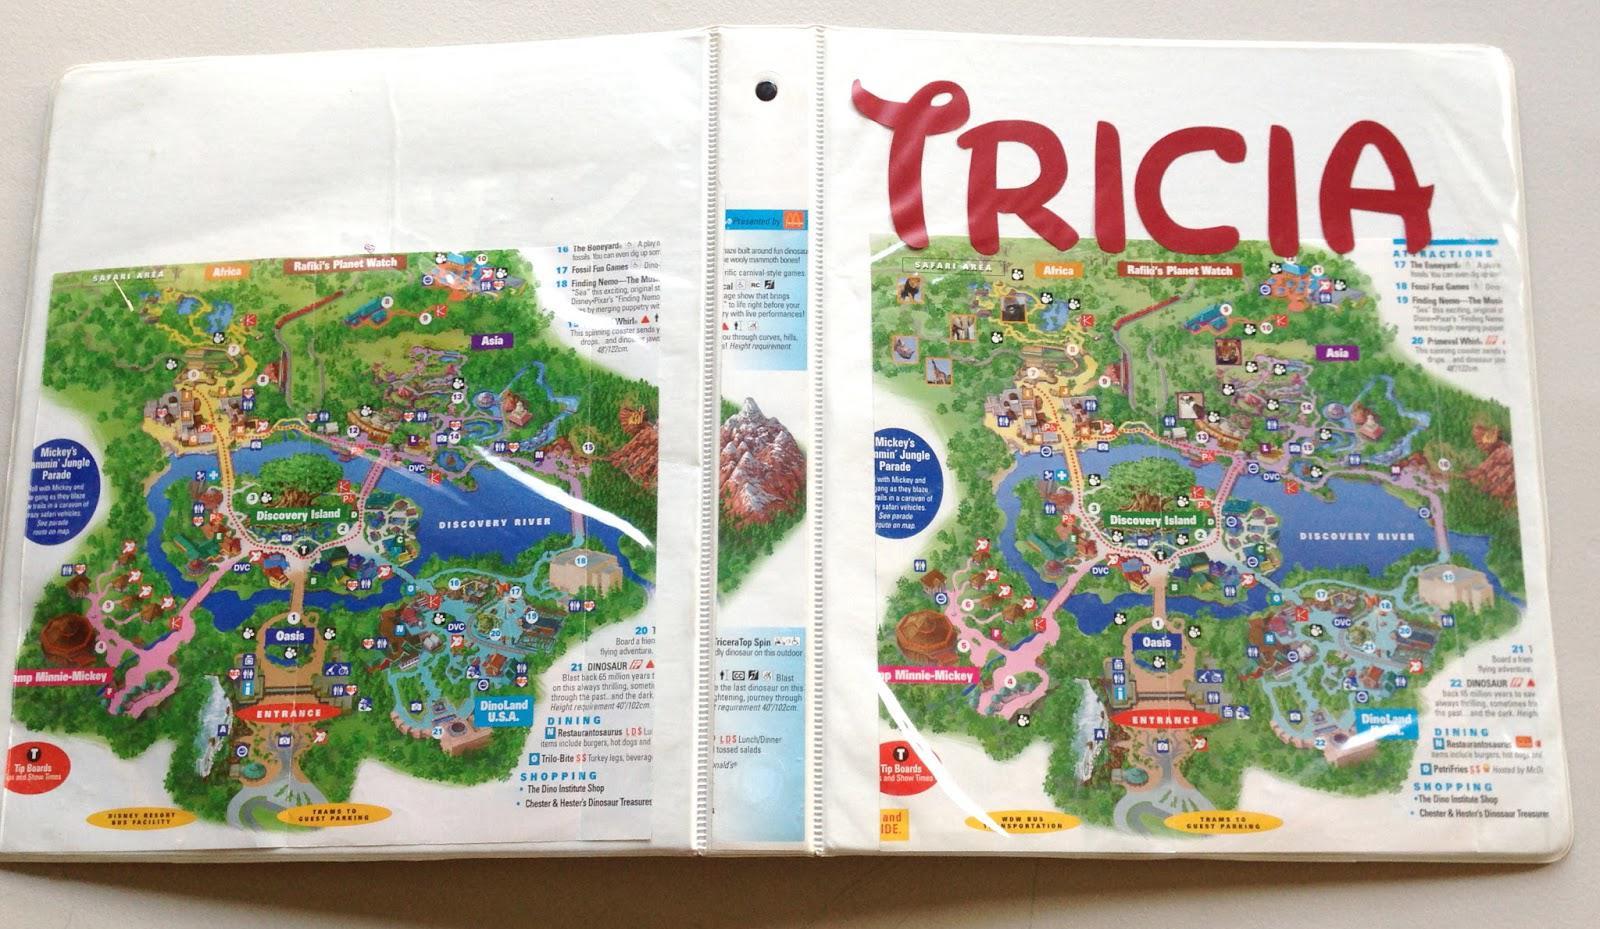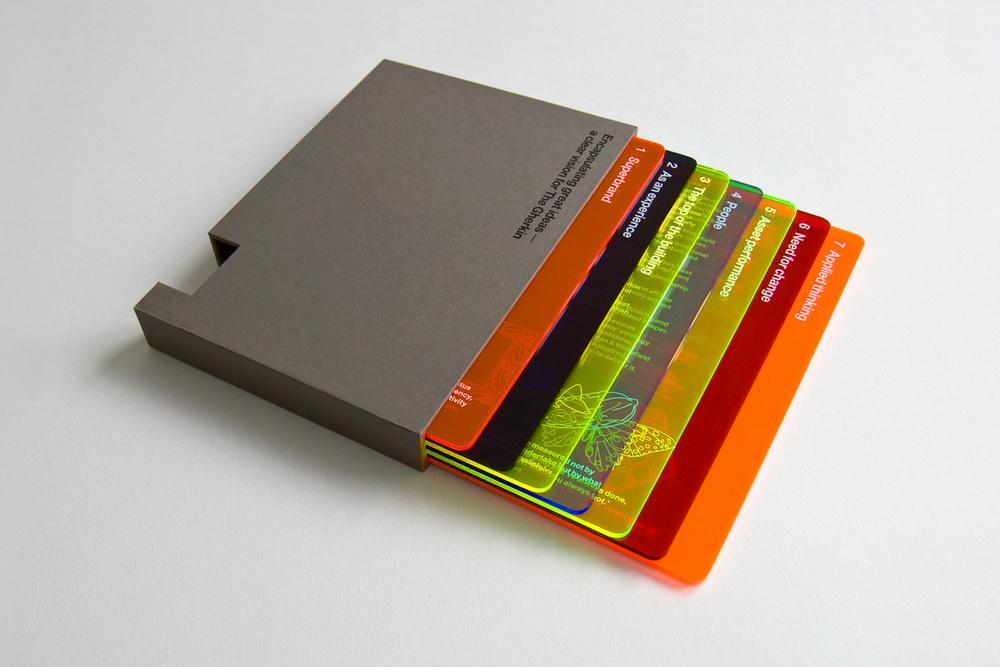The first image is the image on the left, the second image is the image on the right. For the images shown, is this caption "One of the binders has an interior pocket containing a calculator." true? Answer yes or no. No. 